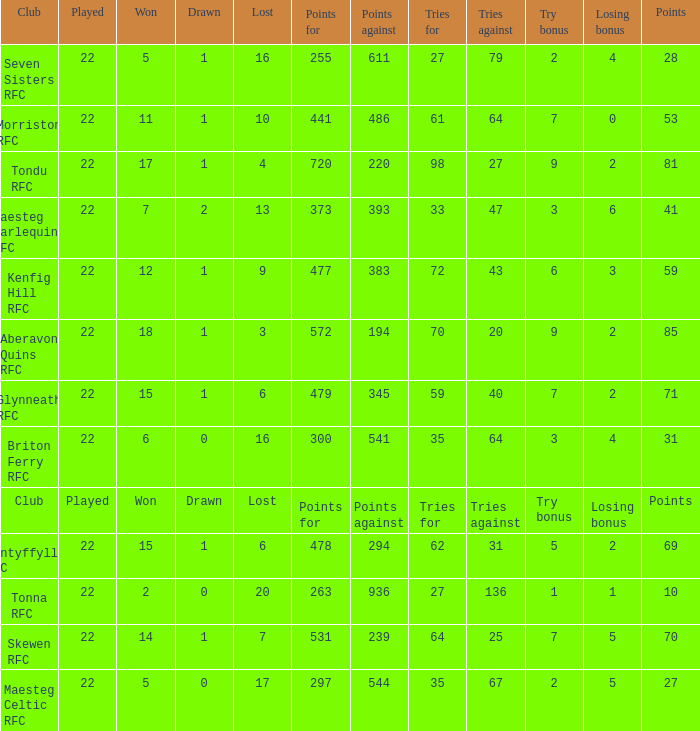Would you mind parsing the complete table? {'header': ['Club', 'Played', 'Won', 'Drawn', 'Lost', 'Points for', 'Points against', 'Tries for', 'Tries against', 'Try bonus', 'Losing bonus', 'Points'], 'rows': [['Seven Sisters RFC', '22', '5', '1', '16', '255', '611', '27', '79', '2', '4', '28'], ['Morriston RFC', '22', '11', '1', '10', '441', '486', '61', '64', '7', '0', '53'], ['Tondu RFC', '22', '17', '1', '4', '720', '220', '98', '27', '9', '2', '81'], ['Maesteg Harlequins RFC', '22', '7', '2', '13', '373', '393', '33', '47', '3', '6', '41'], ['Kenfig Hill RFC', '22', '12', '1', '9', '477', '383', '72', '43', '6', '3', '59'], ['Aberavon Quins RFC', '22', '18', '1', '3', '572', '194', '70', '20', '9', '2', '85'], ['Glynneath RFC', '22', '15', '1', '6', '479', '345', '59', '40', '7', '2', '71'], ['Briton Ferry RFC', '22', '6', '0', '16', '300', '541', '35', '64', '3', '4', '31'], ['Club', 'Played', 'Won', 'Drawn', 'Lost', 'Points for', 'Points against', 'Tries for', 'Tries against', 'Try bonus', 'Losing bonus', 'Points'], ['Nantyffyllon RFC', '22', '15', '1', '6', '478', '294', '62', '31', '5', '2', '69'], ['Tonna RFC', '22', '2', '0', '20', '263', '936', '27', '136', '1', '1', '10'], ['Skewen RFC', '22', '14', '1', '7', '531', '239', '64', '25', '7', '5', '70'], ['Maesteg Celtic RFC', '22', '5', '0', '17', '297', '544', '35', '67', '2', '5', '27']]} What club got 239 points against? Skewen RFC. 